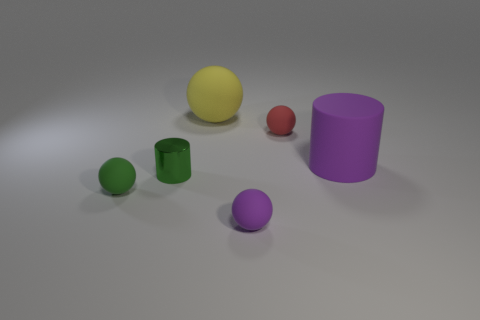Is there anything else that has the same material as the green cylinder?
Offer a very short reply. No. Is the number of large objects that are behind the small red sphere greater than the number of large red metal cylinders?
Offer a terse response. Yes. There is a tiny green thing that is in front of the green shiny cylinder left of the purple matte cylinder; are there any things that are right of it?
Offer a terse response. Yes. Are there any big purple things behind the yellow object?
Your answer should be compact. No. What number of big things have the same color as the tiny metallic object?
Provide a short and direct response. 0. The green object that is the same material as the small red object is what size?
Provide a succinct answer. Small. There is a purple thing that is behind the small rubber sphere that is to the left of the big matte thing that is behind the purple matte cylinder; what is its size?
Make the answer very short. Large. There is a cylinder on the left side of the large yellow matte object; what size is it?
Give a very brief answer. Small. How many brown things are metal objects or big cylinders?
Your answer should be compact. 0. Is there a green cylinder of the same size as the yellow ball?
Provide a succinct answer. No. 